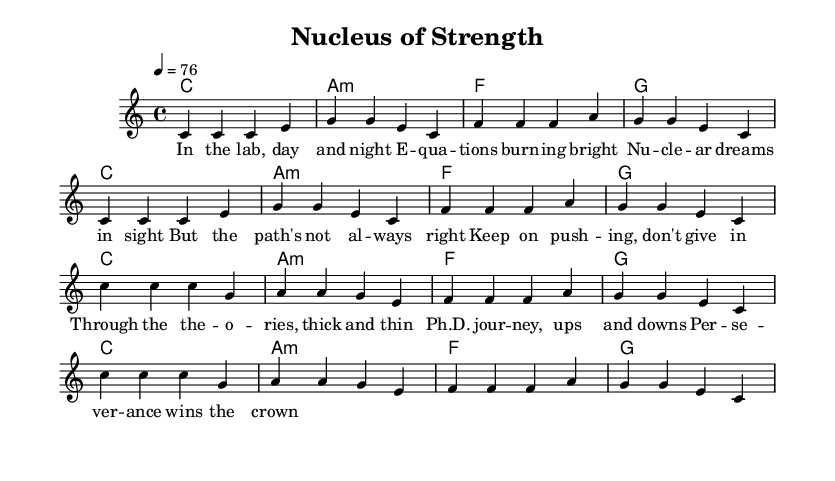What is the key signature of this music? The key signature is C major, which has no sharps or flats, as indicated at the beginning of the piece.
Answer: C major What is the time signature? The time signature indicated is 4/4, which means there are four beats in a measure and the quarter note gets one beat.
Answer: 4/4 What is the tempo marking? The tempo marking is 4 equals 76, meaning the piece is to be played at a speed of 76 beats per minute.
Answer: 76 How many measures are in the verse section? The verse section consists of two repeated phrases, each with four measures, totaling 8 measures.
Answer: 8 measures What is the main theme of the lyrics? The lyrics convey a theme of perseverance in academic challenges, emphasizing determination and resilience.
Answer: Perseverance Which chord appears most frequently in the song? The chord C major appears in every repeated section, indicating it plays a central role in the harmony throughout the piece.
Answer: C major 